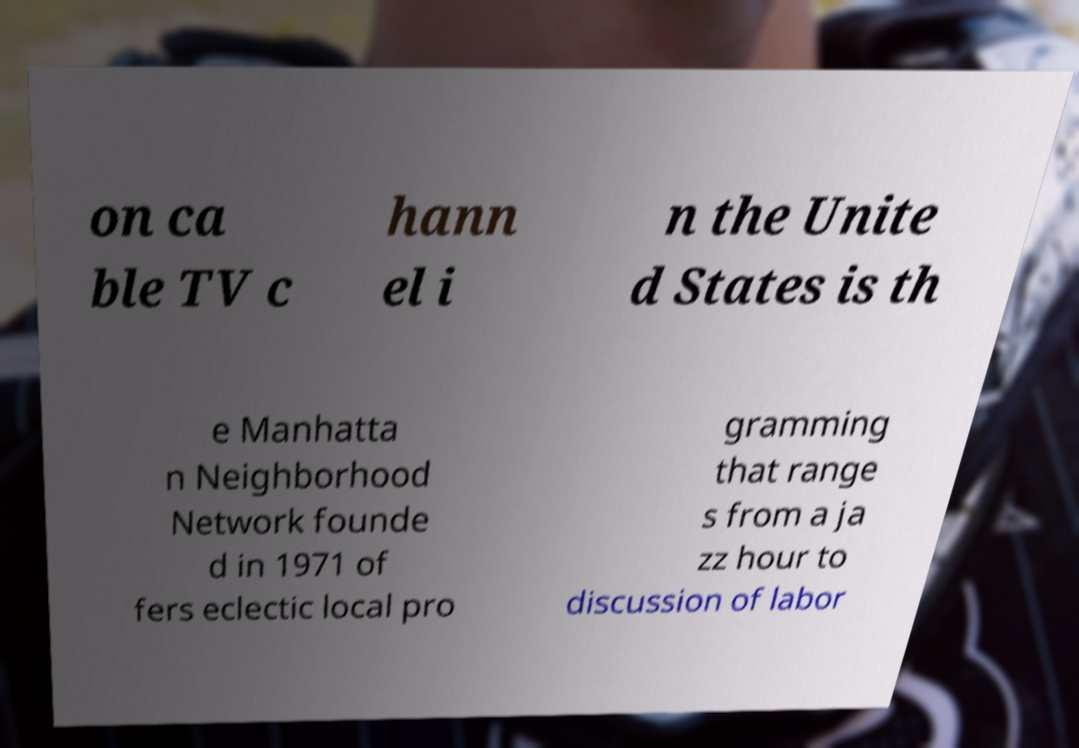There's text embedded in this image that I need extracted. Can you transcribe it verbatim? on ca ble TV c hann el i n the Unite d States is th e Manhatta n Neighborhood Network founde d in 1971 of fers eclectic local pro gramming that range s from a ja zz hour to discussion of labor 